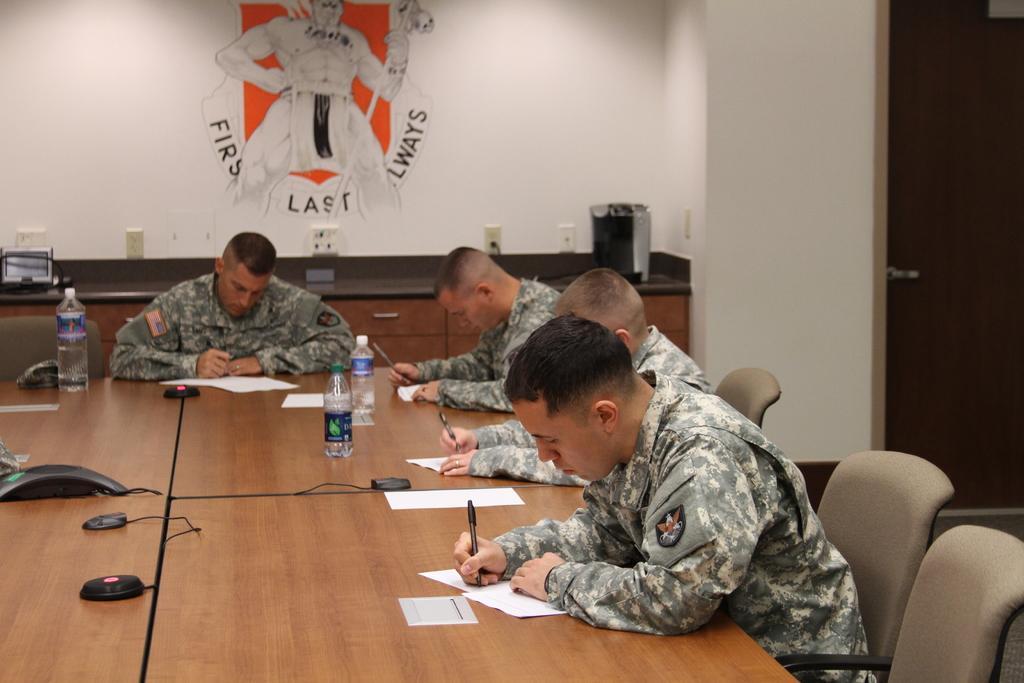Can you describe this image briefly? In this picture, we can see a few people sitting on the chair and writing on papers, we can see some objects on the table and we can see door, we can see an art on the wall and some objects on the desk attached to the wall. 